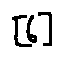<formula> <loc_0><loc_0><loc_500><loc_500>[ 6 ]</formula> 